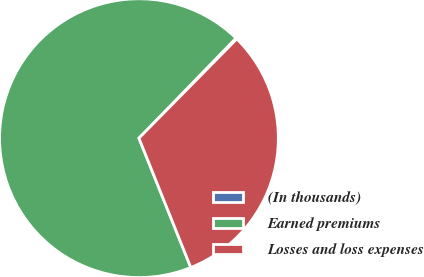Convert chart. <chart><loc_0><loc_0><loc_500><loc_500><pie_chart><fcel>(In thousands)<fcel>Earned premiums<fcel>Losses and loss expenses<nl><fcel>0.13%<fcel>68.32%<fcel>31.54%<nl></chart> 